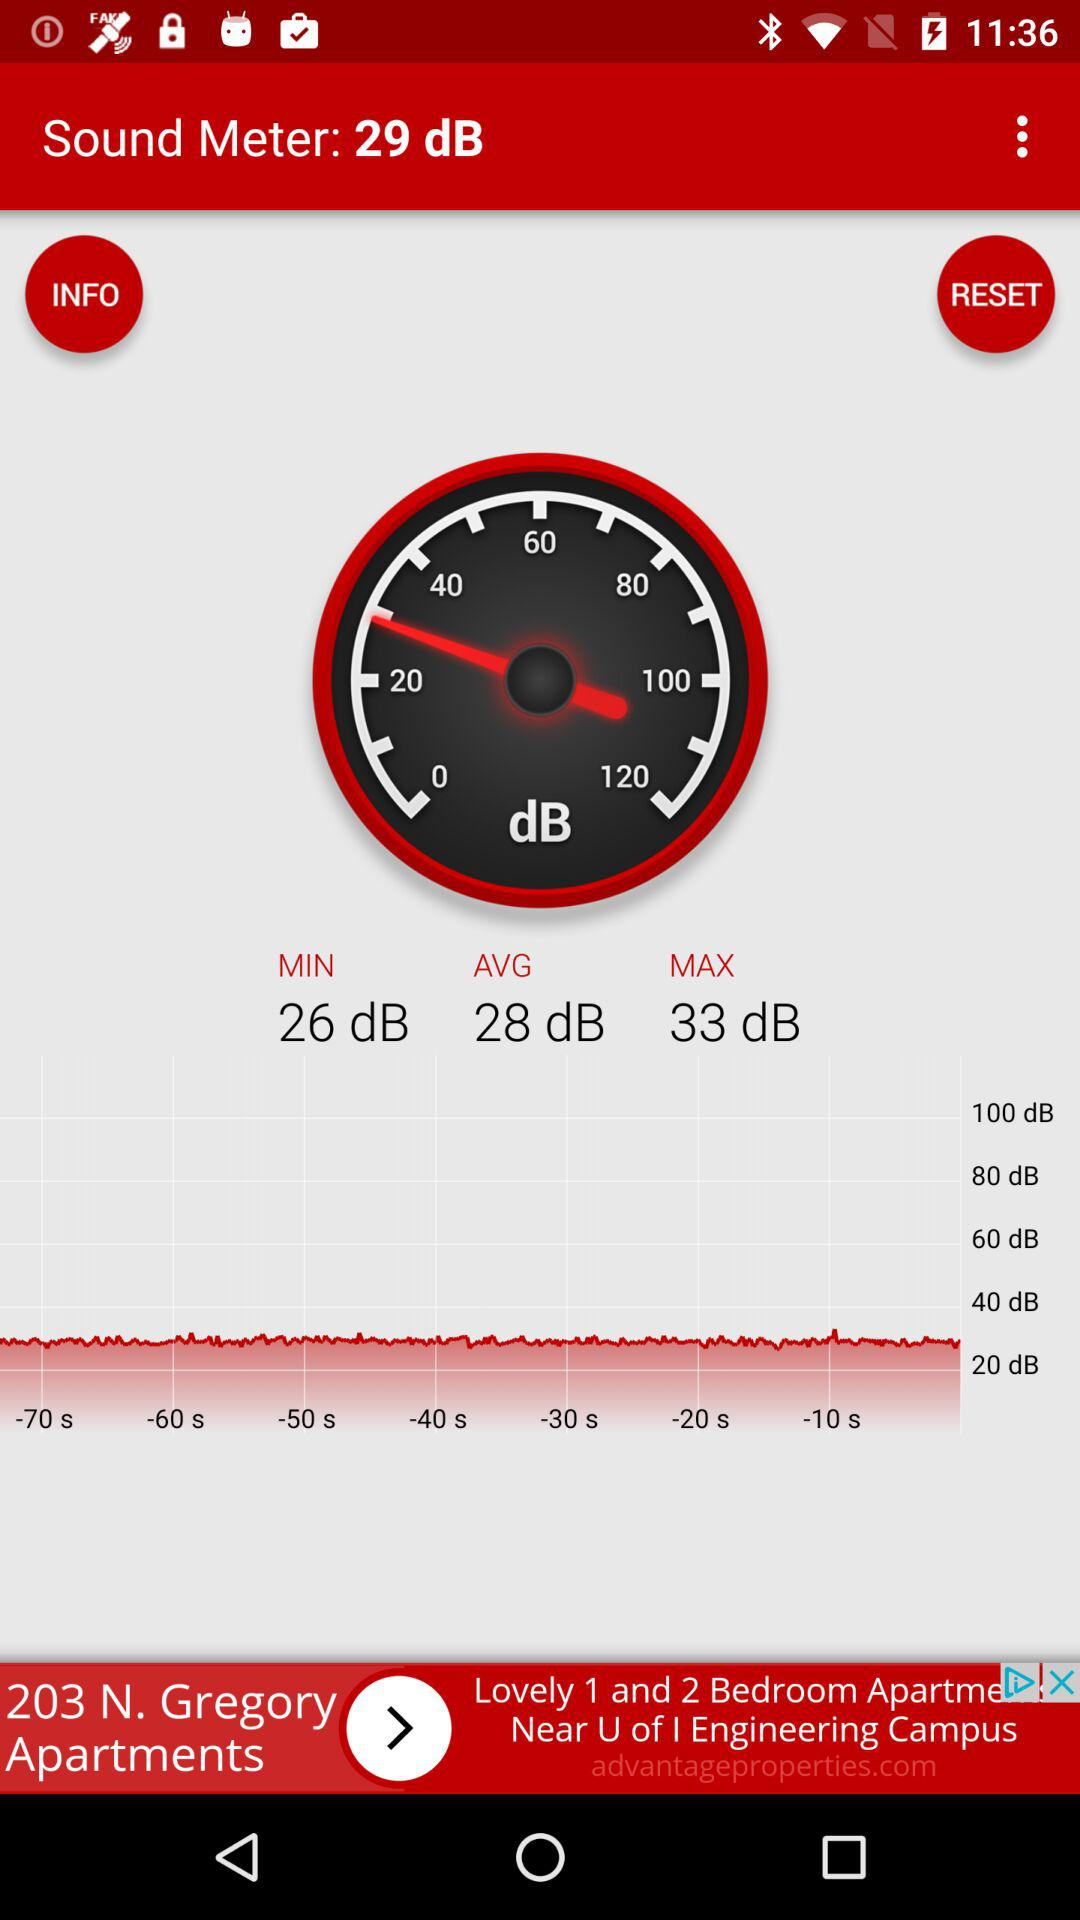What is the average unit in a speed meter? The average unit in a speed meter is 28 dB. 